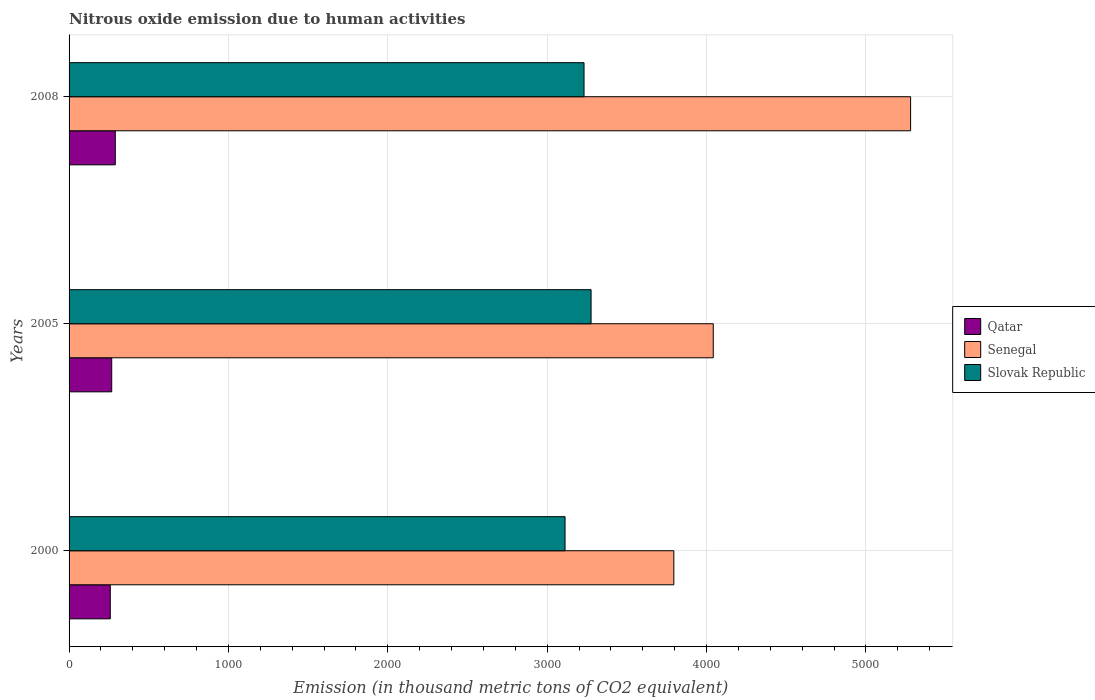How many different coloured bars are there?
Give a very brief answer. 3. Are the number of bars on each tick of the Y-axis equal?
Your answer should be compact. Yes. How many bars are there on the 3rd tick from the bottom?
Offer a very short reply. 3. What is the label of the 3rd group of bars from the top?
Make the answer very short. 2000. What is the amount of nitrous oxide emitted in Qatar in 2000?
Offer a terse response. 258.6. Across all years, what is the maximum amount of nitrous oxide emitted in Senegal?
Provide a succinct answer. 5280.7. Across all years, what is the minimum amount of nitrous oxide emitted in Slovak Republic?
Provide a succinct answer. 3112.3. In which year was the amount of nitrous oxide emitted in Qatar maximum?
Provide a succinct answer. 2008. What is the total amount of nitrous oxide emitted in Slovak Republic in the graph?
Ensure brevity in your answer.  9619.3. What is the difference between the amount of nitrous oxide emitted in Senegal in 2000 and that in 2005?
Keep it short and to the point. -247.5. What is the difference between the amount of nitrous oxide emitted in Senegal in 2005 and the amount of nitrous oxide emitted in Qatar in 2008?
Your answer should be compact. 3752.3. What is the average amount of nitrous oxide emitted in Slovak Republic per year?
Offer a very short reply. 3206.43. In the year 2000, what is the difference between the amount of nitrous oxide emitted in Qatar and amount of nitrous oxide emitted in Senegal?
Keep it short and to the point. -3536.3. In how many years, is the amount of nitrous oxide emitted in Qatar greater than 1400 thousand metric tons?
Your response must be concise. 0. What is the ratio of the amount of nitrous oxide emitted in Senegal in 2005 to that in 2008?
Make the answer very short. 0.77. What is the difference between the highest and the second highest amount of nitrous oxide emitted in Senegal?
Your response must be concise. 1238.3. What is the difference between the highest and the lowest amount of nitrous oxide emitted in Senegal?
Keep it short and to the point. 1485.8. Is the sum of the amount of nitrous oxide emitted in Qatar in 2000 and 2008 greater than the maximum amount of nitrous oxide emitted in Slovak Republic across all years?
Provide a short and direct response. No. What does the 1st bar from the top in 2008 represents?
Make the answer very short. Slovak Republic. What does the 1st bar from the bottom in 2005 represents?
Offer a terse response. Qatar. Is it the case that in every year, the sum of the amount of nitrous oxide emitted in Slovak Republic and amount of nitrous oxide emitted in Qatar is greater than the amount of nitrous oxide emitted in Senegal?
Provide a succinct answer. No. Are all the bars in the graph horizontal?
Provide a short and direct response. Yes. What is the difference between two consecutive major ticks on the X-axis?
Ensure brevity in your answer.  1000. Are the values on the major ticks of X-axis written in scientific E-notation?
Keep it short and to the point. No. Does the graph contain any zero values?
Your answer should be compact. No. Does the graph contain grids?
Your answer should be very brief. Yes. How many legend labels are there?
Provide a succinct answer. 3. How are the legend labels stacked?
Offer a terse response. Vertical. What is the title of the graph?
Your response must be concise. Nitrous oxide emission due to human activities. Does "Poland" appear as one of the legend labels in the graph?
Your response must be concise. No. What is the label or title of the X-axis?
Your answer should be compact. Emission (in thousand metric tons of CO2 equivalent). What is the Emission (in thousand metric tons of CO2 equivalent) in Qatar in 2000?
Ensure brevity in your answer.  258.6. What is the Emission (in thousand metric tons of CO2 equivalent) in Senegal in 2000?
Your answer should be compact. 3794.9. What is the Emission (in thousand metric tons of CO2 equivalent) in Slovak Republic in 2000?
Offer a very short reply. 3112.3. What is the Emission (in thousand metric tons of CO2 equivalent) in Qatar in 2005?
Provide a succinct answer. 267.6. What is the Emission (in thousand metric tons of CO2 equivalent) in Senegal in 2005?
Provide a short and direct response. 4042.4. What is the Emission (in thousand metric tons of CO2 equivalent) in Slovak Republic in 2005?
Offer a terse response. 3275.6. What is the Emission (in thousand metric tons of CO2 equivalent) of Qatar in 2008?
Your response must be concise. 290.1. What is the Emission (in thousand metric tons of CO2 equivalent) of Senegal in 2008?
Give a very brief answer. 5280.7. What is the Emission (in thousand metric tons of CO2 equivalent) in Slovak Republic in 2008?
Your response must be concise. 3231.4. Across all years, what is the maximum Emission (in thousand metric tons of CO2 equivalent) of Qatar?
Your answer should be very brief. 290.1. Across all years, what is the maximum Emission (in thousand metric tons of CO2 equivalent) of Senegal?
Ensure brevity in your answer.  5280.7. Across all years, what is the maximum Emission (in thousand metric tons of CO2 equivalent) in Slovak Republic?
Make the answer very short. 3275.6. Across all years, what is the minimum Emission (in thousand metric tons of CO2 equivalent) of Qatar?
Your answer should be very brief. 258.6. Across all years, what is the minimum Emission (in thousand metric tons of CO2 equivalent) in Senegal?
Ensure brevity in your answer.  3794.9. Across all years, what is the minimum Emission (in thousand metric tons of CO2 equivalent) in Slovak Republic?
Ensure brevity in your answer.  3112.3. What is the total Emission (in thousand metric tons of CO2 equivalent) of Qatar in the graph?
Provide a succinct answer. 816.3. What is the total Emission (in thousand metric tons of CO2 equivalent) of Senegal in the graph?
Your answer should be very brief. 1.31e+04. What is the total Emission (in thousand metric tons of CO2 equivalent) of Slovak Republic in the graph?
Your response must be concise. 9619.3. What is the difference between the Emission (in thousand metric tons of CO2 equivalent) in Qatar in 2000 and that in 2005?
Offer a terse response. -9. What is the difference between the Emission (in thousand metric tons of CO2 equivalent) in Senegal in 2000 and that in 2005?
Your response must be concise. -247.5. What is the difference between the Emission (in thousand metric tons of CO2 equivalent) in Slovak Republic in 2000 and that in 2005?
Your answer should be very brief. -163.3. What is the difference between the Emission (in thousand metric tons of CO2 equivalent) of Qatar in 2000 and that in 2008?
Ensure brevity in your answer.  -31.5. What is the difference between the Emission (in thousand metric tons of CO2 equivalent) in Senegal in 2000 and that in 2008?
Provide a short and direct response. -1485.8. What is the difference between the Emission (in thousand metric tons of CO2 equivalent) in Slovak Republic in 2000 and that in 2008?
Offer a very short reply. -119.1. What is the difference between the Emission (in thousand metric tons of CO2 equivalent) in Qatar in 2005 and that in 2008?
Your response must be concise. -22.5. What is the difference between the Emission (in thousand metric tons of CO2 equivalent) of Senegal in 2005 and that in 2008?
Your answer should be very brief. -1238.3. What is the difference between the Emission (in thousand metric tons of CO2 equivalent) in Slovak Republic in 2005 and that in 2008?
Offer a very short reply. 44.2. What is the difference between the Emission (in thousand metric tons of CO2 equivalent) of Qatar in 2000 and the Emission (in thousand metric tons of CO2 equivalent) of Senegal in 2005?
Offer a very short reply. -3783.8. What is the difference between the Emission (in thousand metric tons of CO2 equivalent) of Qatar in 2000 and the Emission (in thousand metric tons of CO2 equivalent) of Slovak Republic in 2005?
Ensure brevity in your answer.  -3017. What is the difference between the Emission (in thousand metric tons of CO2 equivalent) of Senegal in 2000 and the Emission (in thousand metric tons of CO2 equivalent) of Slovak Republic in 2005?
Keep it short and to the point. 519.3. What is the difference between the Emission (in thousand metric tons of CO2 equivalent) in Qatar in 2000 and the Emission (in thousand metric tons of CO2 equivalent) in Senegal in 2008?
Your answer should be very brief. -5022.1. What is the difference between the Emission (in thousand metric tons of CO2 equivalent) in Qatar in 2000 and the Emission (in thousand metric tons of CO2 equivalent) in Slovak Republic in 2008?
Your response must be concise. -2972.8. What is the difference between the Emission (in thousand metric tons of CO2 equivalent) of Senegal in 2000 and the Emission (in thousand metric tons of CO2 equivalent) of Slovak Republic in 2008?
Your answer should be compact. 563.5. What is the difference between the Emission (in thousand metric tons of CO2 equivalent) of Qatar in 2005 and the Emission (in thousand metric tons of CO2 equivalent) of Senegal in 2008?
Make the answer very short. -5013.1. What is the difference between the Emission (in thousand metric tons of CO2 equivalent) in Qatar in 2005 and the Emission (in thousand metric tons of CO2 equivalent) in Slovak Republic in 2008?
Give a very brief answer. -2963.8. What is the difference between the Emission (in thousand metric tons of CO2 equivalent) in Senegal in 2005 and the Emission (in thousand metric tons of CO2 equivalent) in Slovak Republic in 2008?
Ensure brevity in your answer.  811. What is the average Emission (in thousand metric tons of CO2 equivalent) in Qatar per year?
Provide a succinct answer. 272.1. What is the average Emission (in thousand metric tons of CO2 equivalent) in Senegal per year?
Provide a succinct answer. 4372.67. What is the average Emission (in thousand metric tons of CO2 equivalent) in Slovak Republic per year?
Your answer should be very brief. 3206.43. In the year 2000, what is the difference between the Emission (in thousand metric tons of CO2 equivalent) in Qatar and Emission (in thousand metric tons of CO2 equivalent) in Senegal?
Give a very brief answer. -3536.3. In the year 2000, what is the difference between the Emission (in thousand metric tons of CO2 equivalent) in Qatar and Emission (in thousand metric tons of CO2 equivalent) in Slovak Republic?
Keep it short and to the point. -2853.7. In the year 2000, what is the difference between the Emission (in thousand metric tons of CO2 equivalent) in Senegal and Emission (in thousand metric tons of CO2 equivalent) in Slovak Republic?
Give a very brief answer. 682.6. In the year 2005, what is the difference between the Emission (in thousand metric tons of CO2 equivalent) of Qatar and Emission (in thousand metric tons of CO2 equivalent) of Senegal?
Offer a terse response. -3774.8. In the year 2005, what is the difference between the Emission (in thousand metric tons of CO2 equivalent) in Qatar and Emission (in thousand metric tons of CO2 equivalent) in Slovak Republic?
Make the answer very short. -3008. In the year 2005, what is the difference between the Emission (in thousand metric tons of CO2 equivalent) of Senegal and Emission (in thousand metric tons of CO2 equivalent) of Slovak Republic?
Give a very brief answer. 766.8. In the year 2008, what is the difference between the Emission (in thousand metric tons of CO2 equivalent) of Qatar and Emission (in thousand metric tons of CO2 equivalent) of Senegal?
Ensure brevity in your answer.  -4990.6. In the year 2008, what is the difference between the Emission (in thousand metric tons of CO2 equivalent) in Qatar and Emission (in thousand metric tons of CO2 equivalent) in Slovak Republic?
Make the answer very short. -2941.3. In the year 2008, what is the difference between the Emission (in thousand metric tons of CO2 equivalent) of Senegal and Emission (in thousand metric tons of CO2 equivalent) of Slovak Republic?
Ensure brevity in your answer.  2049.3. What is the ratio of the Emission (in thousand metric tons of CO2 equivalent) of Qatar in 2000 to that in 2005?
Your answer should be compact. 0.97. What is the ratio of the Emission (in thousand metric tons of CO2 equivalent) of Senegal in 2000 to that in 2005?
Your answer should be very brief. 0.94. What is the ratio of the Emission (in thousand metric tons of CO2 equivalent) in Slovak Republic in 2000 to that in 2005?
Give a very brief answer. 0.95. What is the ratio of the Emission (in thousand metric tons of CO2 equivalent) of Qatar in 2000 to that in 2008?
Provide a succinct answer. 0.89. What is the ratio of the Emission (in thousand metric tons of CO2 equivalent) in Senegal in 2000 to that in 2008?
Provide a short and direct response. 0.72. What is the ratio of the Emission (in thousand metric tons of CO2 equivalent) of Slovak Republic in 2000 to that in 2008?
Your answer should be compact. 0.96. What is the ratio of the Emission (in thousand metric tons of CO2 equivalent) in Qatar in 2005 to that in 2008?
Offer a very short reply. 0.92. What is the ratio of the Emission (in thousand metric tons of CO2 equivalent) of Senegal in 2005 to that in 2008?
Provide a short and direct response. 0.77. What is the ratio of the Emission (in thousand metric tons of CO2 equivalent) in Slovak Republic in 2005 to that in 2008?
Your answer should be compact. 1.01. What is the difference between the highest and the second highest Emission (in thousand metric tons of CO2 equivalent) of Senegal?
Give a very brief answer. 1238.3. What is the difference between the highest and the second highest Emission (in thousand metric tons of CO2 equivalent) of Slovak Republic?
Provide a succinct answer. 44.2. What is the difference between the highest and the lowest Emission (in thousand metric tons of CO2 equivalent) of Qatar?
Your answer should be compact. 31.5. What is the difference between the highest and the lowest Emission (in thousand metric tons of CO2 equivalent) of Senegal?
Your answer should be very brief. 1485.8. What is the difference between the highest and the lowest Emission (in thousand metric tons of CO2 equivalent) in Slovak Republic?
Provide a short and direct response. 163.3. 